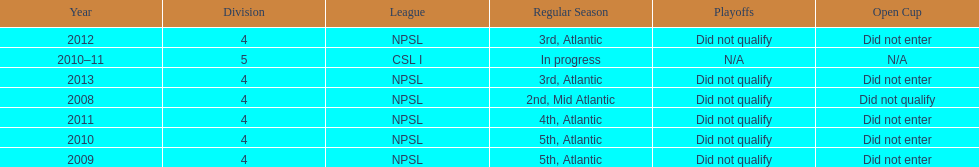How many years did they not qualify for the playoffs? 6. 